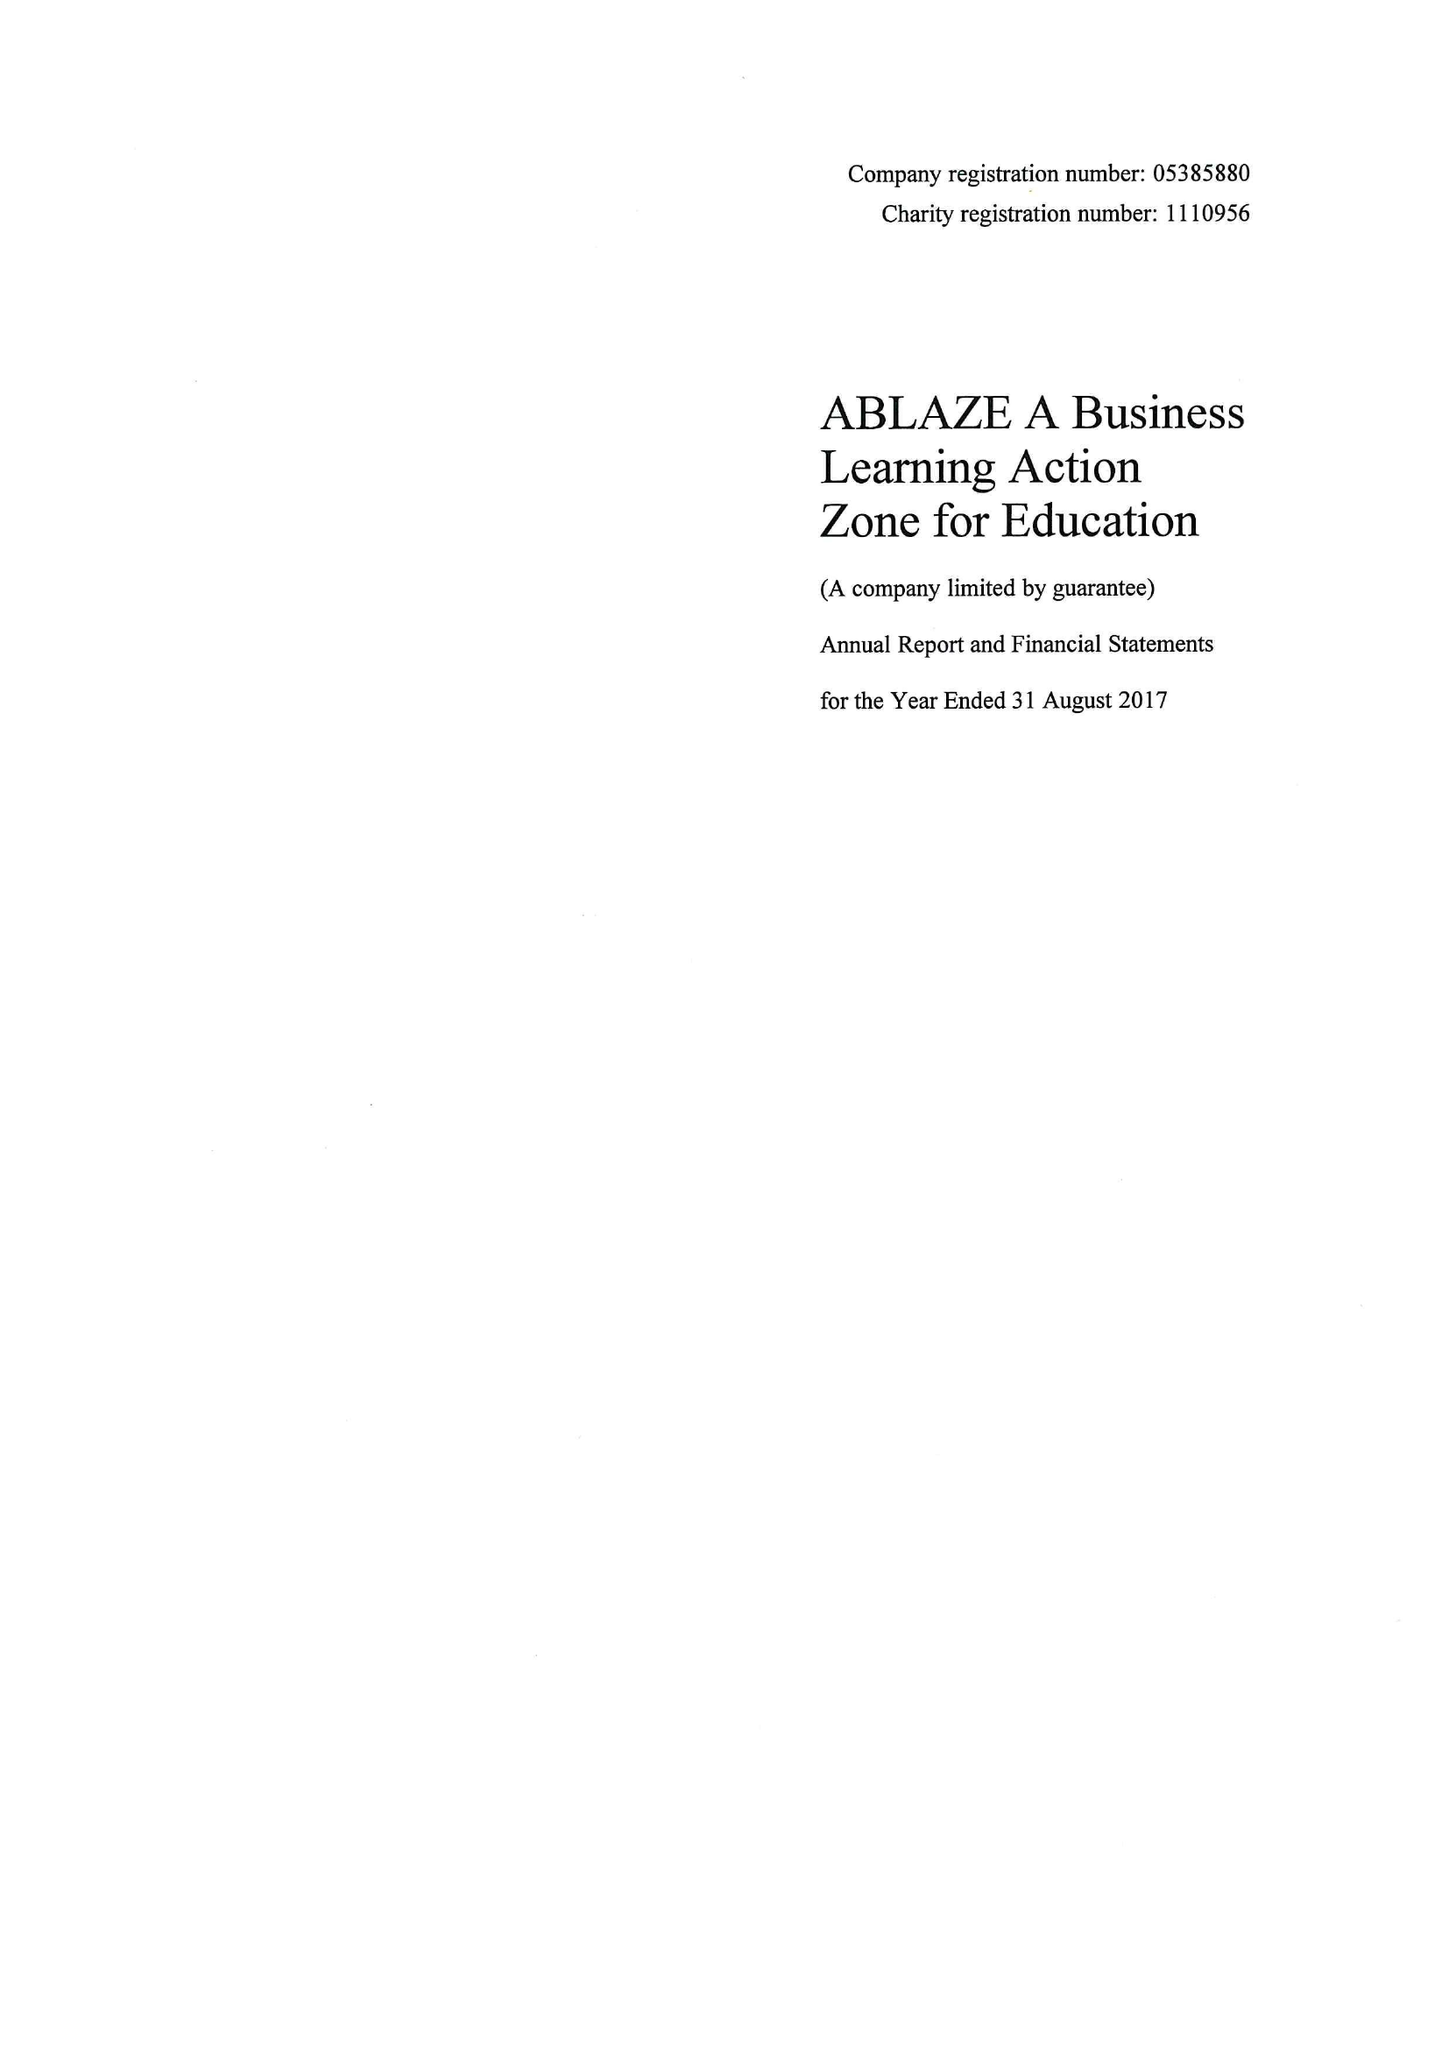What is the value for the income_annually_in_british_pounds?
Answer the question using a single word or phrase. 149921.00 